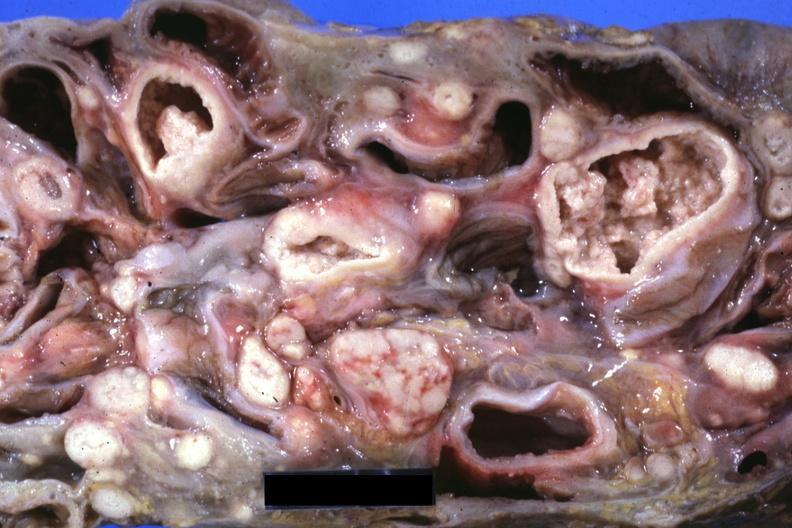does this image show slice through mass of intestines and mesenteric nodes showing lesions that look more like carcinoma but are in fact tuberculosis?
Answer the question using a single word or phrase. Yes 